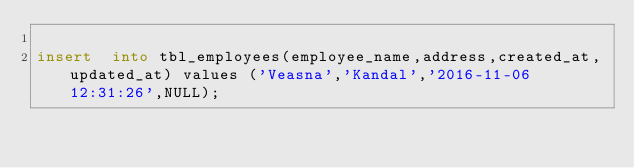Convert code to text. <code><loc_0><loc_0><loc_500><loc_500><_SQL_>
insert  into tbl_employees(employee_name,address,created_at,updated_at) values ('Veasna','Kandal','2016-11-06 12:31:26',NULL);</code> 